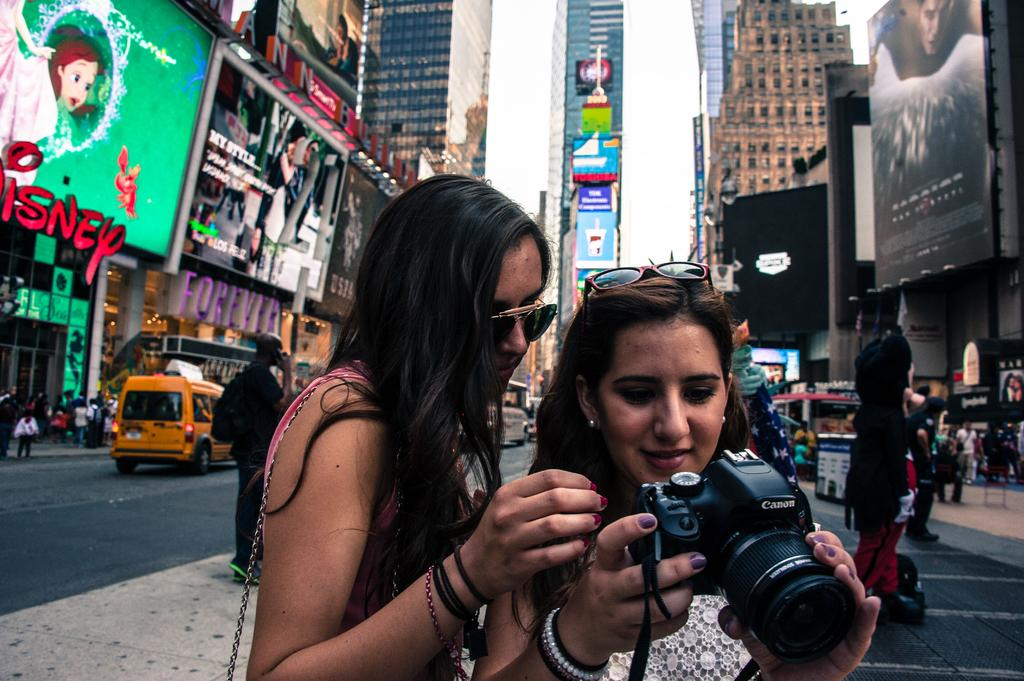Provide a one-sentence caption for the provided image. Two women in New York City look into a Canon brand camera. 